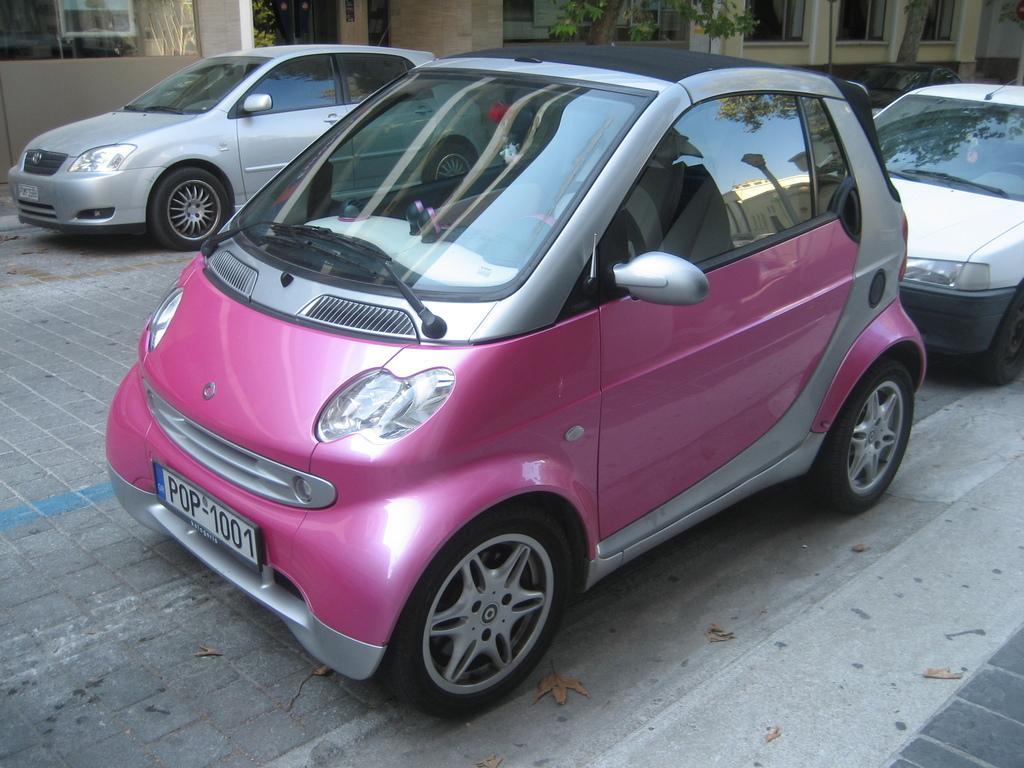Describe this image in one or two sentences. In the picture there are three cars parked on the land and behind the cars there is a complex, it has plenty of windows and there are two trees in front of the complex. 